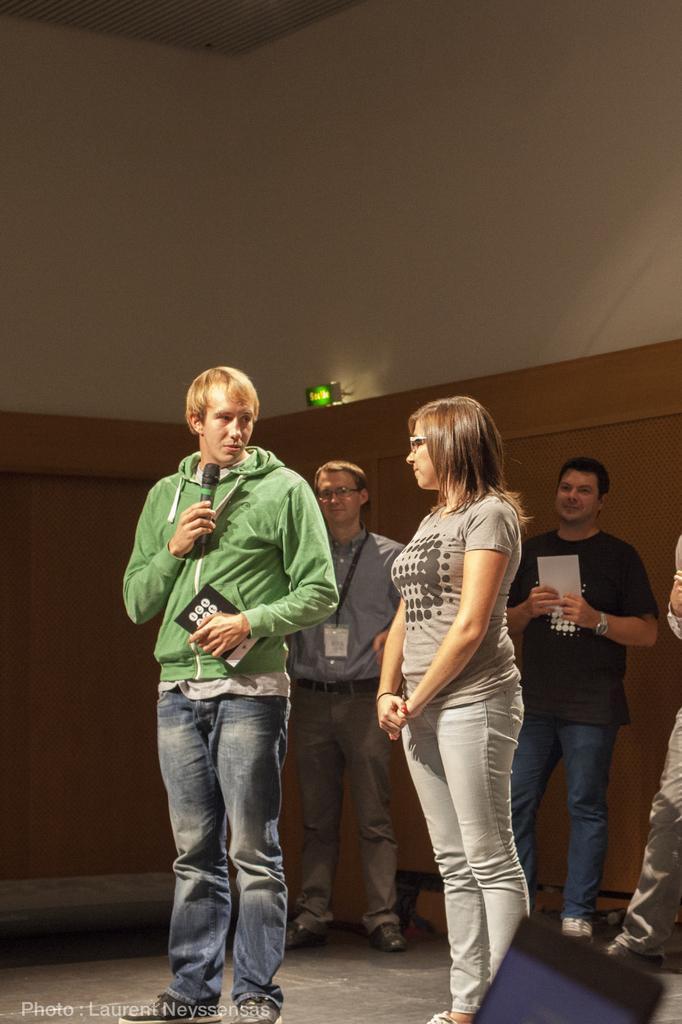How would you summarize this image in a sentence or two? This image consists of a man wearing green jacket, is holding a mic. Beside him, there is a woman standing. At the bottom, there is a floor. In the background, there is a wall along with a light. 